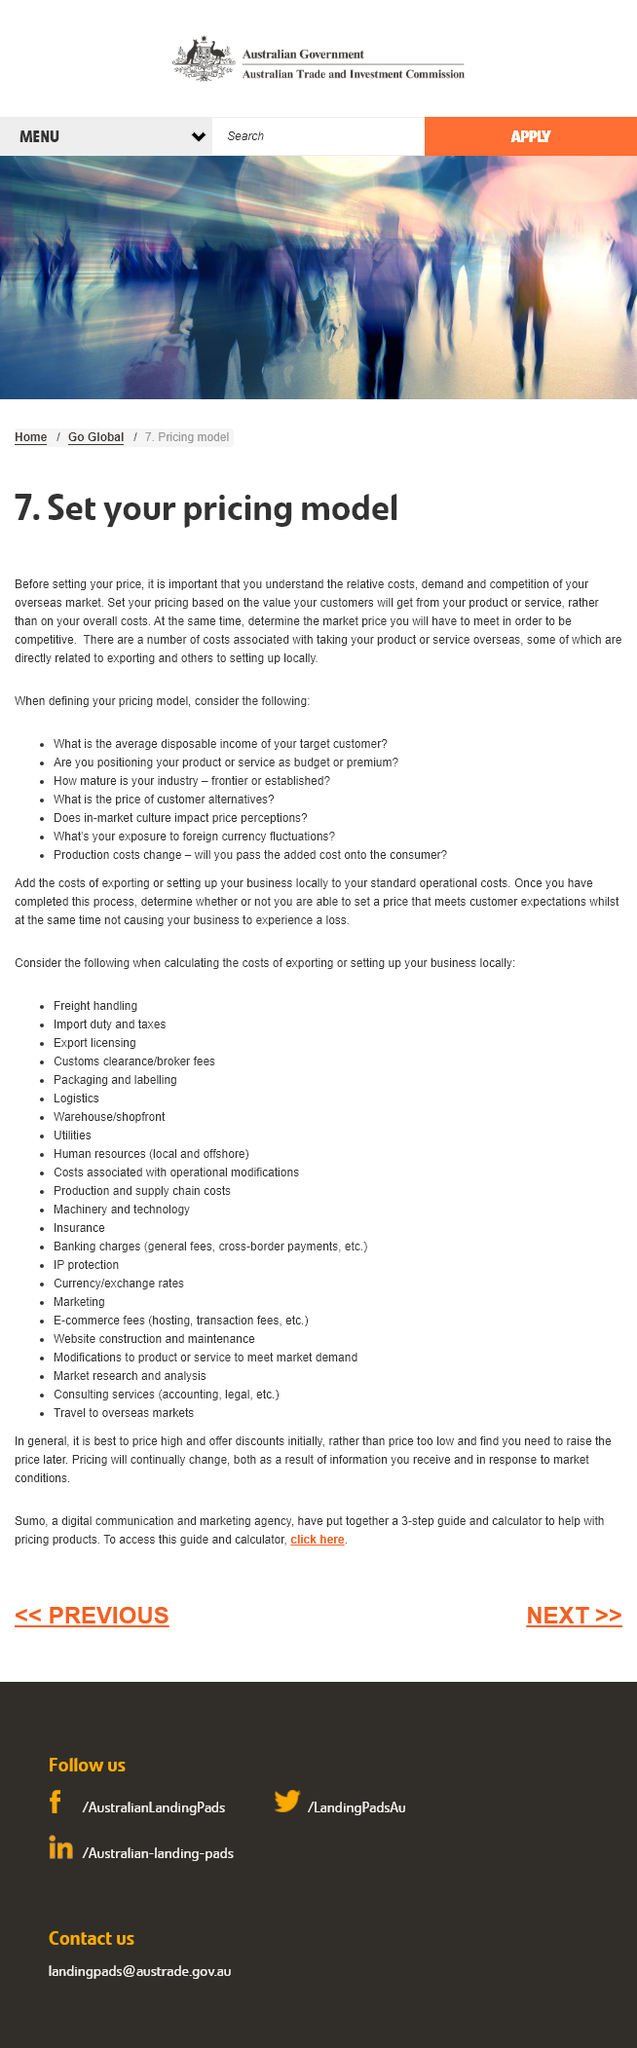List a handful of essential elements in this visual. Considering the maturity of your industry is crucial when defining your pricing model, as it can have a significant impact on your pricing strategy. Yes, there are several costs associated with taking our product or service overseas. It is crucial to comprehend the significance of the overseas market, particularly with regards to the relative costs, demand, and competition that exist within it. 